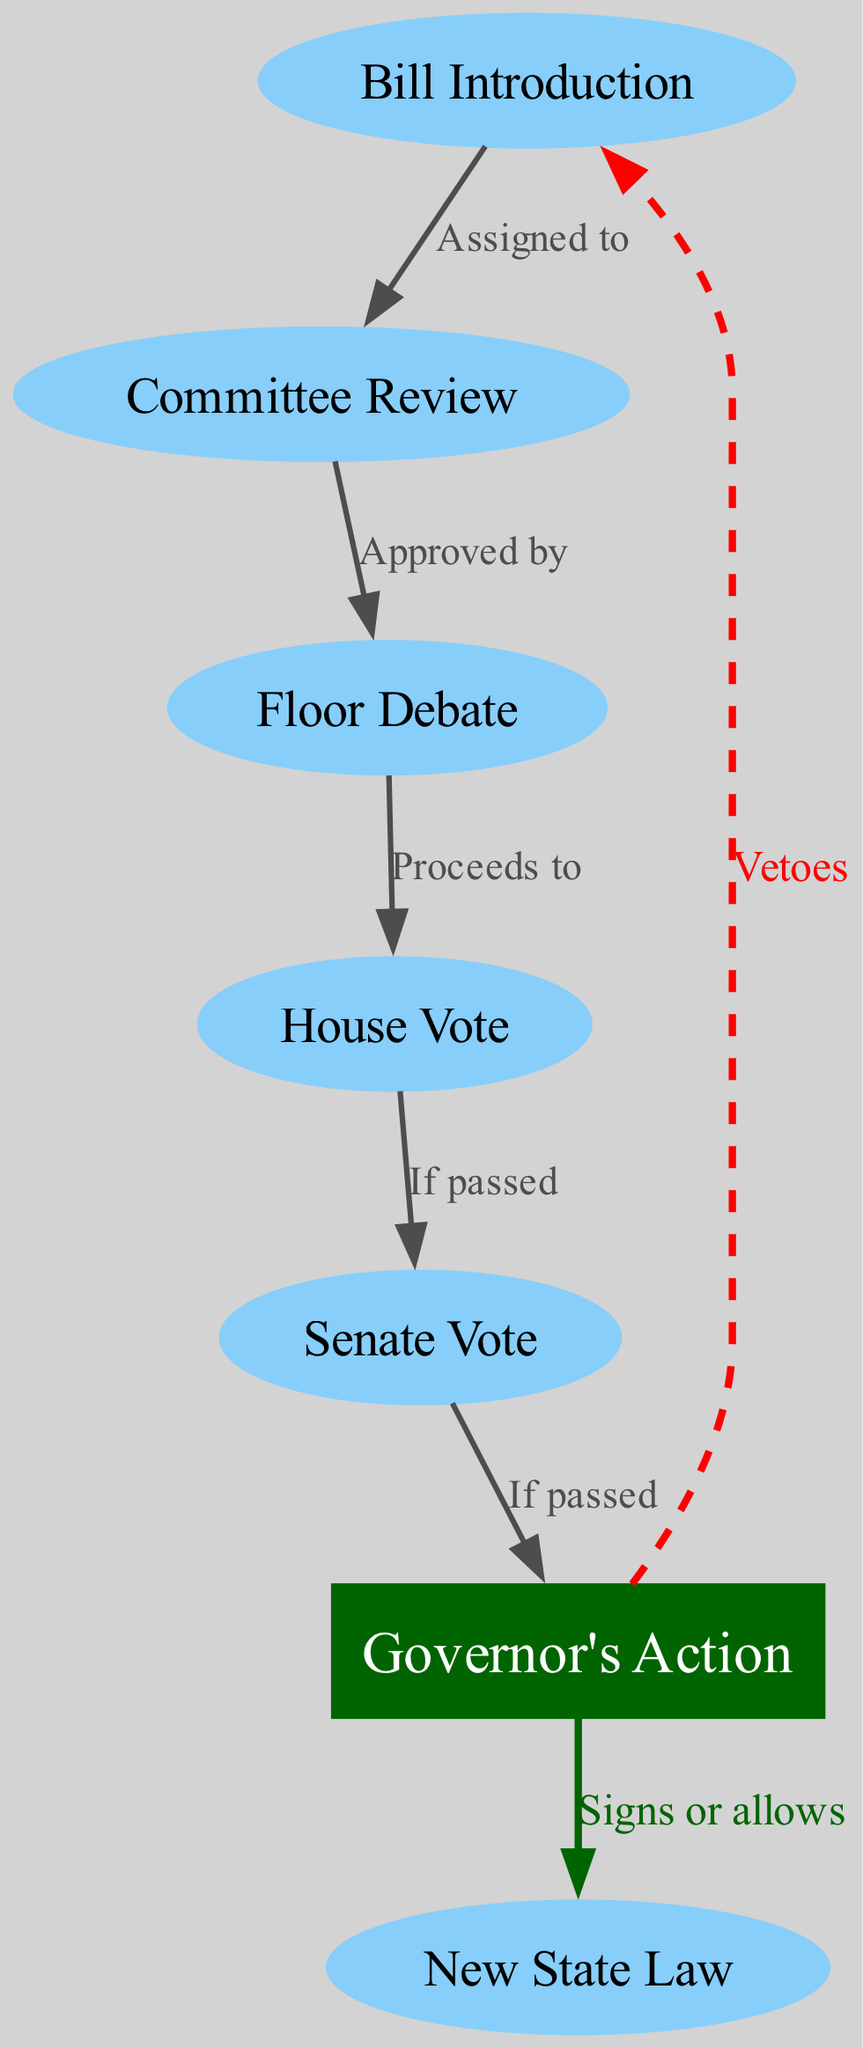What is the first step in the legislative process? The diagram shows the first node labeled "Bill Introduction," which indicates it is the initial step in the legislative process for passing new state laws and regulations.
Answer: Bill Introduction How many nodes are in the diagram? By counting the individual nodes listed in the data, there are a total of seven nodes representing different stages of the legislative process.
Answer: Seven What happens to a bill after "Committee Review"? The diagram indicates that a bill "Proceeds to" the next step, which is "Floor Debate," following "Committee Review," establishing the flow of the process.
Answer: Floor Debate What action can the Governor take after voting in the legislative process? The diagram states that after the Governor's action, he can either "Signs or allows" the bill to become a new state law or "Vetoes" it, indicating two possible actions he can take.
Answer: Signs or allows / Vetoes What is the relationship between "House Vote" and "Senate Vote"? According to the diagram, the relationship indicates that if the bill is "If passed" in the House Vote, it then "proceeds to" the Senate Vote, illustrating the sequential approval process required in the legislative system.
Answer: If passed What color is used to represent the "Governor's Action" node? The diagram uses dark green to fill the node labeled "Governor's Action," which distinguishes it from the other nodes and highlights its importance in the legislative process.
Answer: Dark green Which action indicates that a bill has failed at the Governor's level? The diagram shows that if the Governor decides to "Vetoes" the bill, this indicates a failed attempt to pass the law, demonstrating the Governor's power in the legislative process.
Answer: Vetoes What does the edge labeled "Signs or allows" indicate? The edge labeled "Signs or allows" connects the "Governor's Action" node to "New State Law," signifying the conclusion of the legislative process where the Governor can officially enact the law if he approves it.
Answer: New State Law 